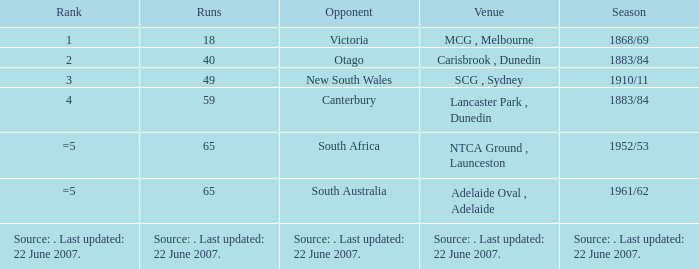Which race features an adversary of canterbury? 59.0. 